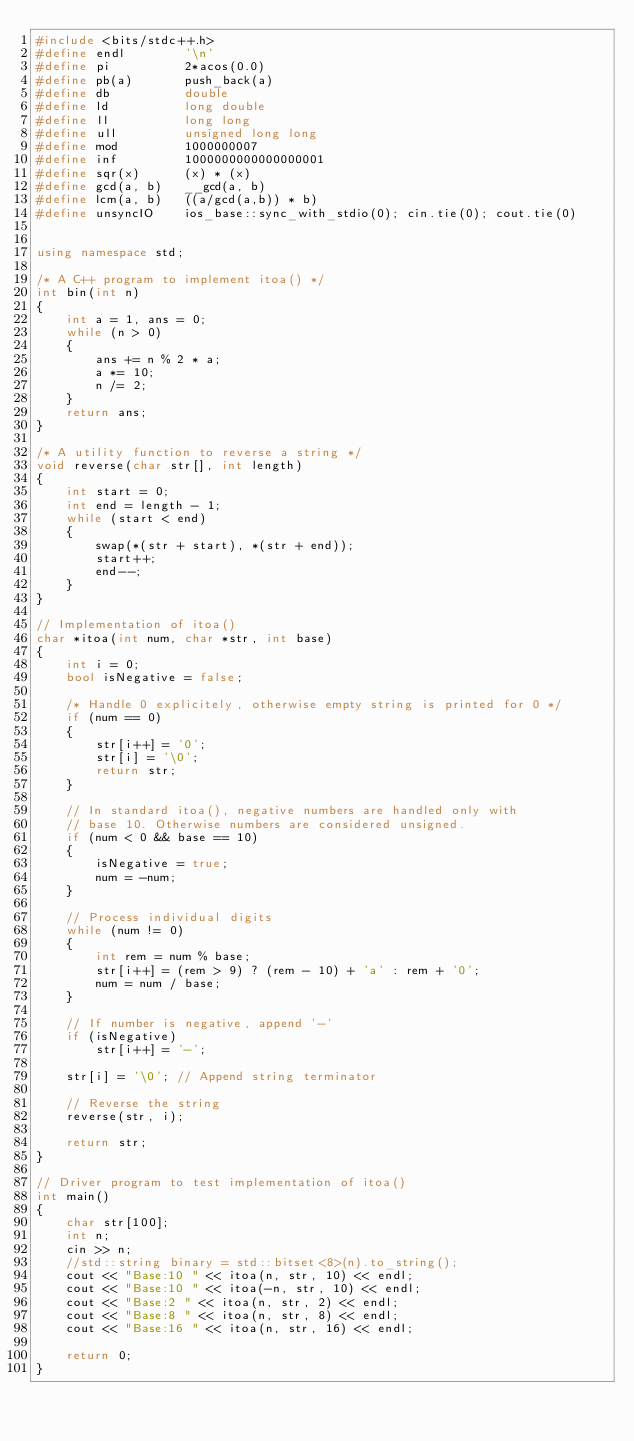Convert code to text. <code><loc_0><loc_0><loc_500><loc_500><_C++_>#include <bits/stdc++.h>
#define endl        '\n'
#define pi          2*acos(0.0)
#define pb(a)       push_back(a)
#define db          double
#define ld          long double
#define ll          long long
#define ull         unsigned long long
#define mod         1000000007
#define inf         1000000000000000001
#define sqr(x)      (x) * (x)
#define gcd(a, b)   __gcd(a, b)
#define lcm(a, b)   ((a/gcd(a,b)) * b) 
#define unsyncIO    ios_base::sync_with_stdio(0); cin.tie(0); cout.tie(0)


using namespace std;

/* A C++ program to implement itoa() */
int bin(int n)
{
    int a = 1, ans = 0;
    while (n > 0)
    {
        ans += n % 2 * a;
        a *= 10;
        n /= 2;
    }
    return ans;
}

/* A utility function to reverse a string */
void reverse(char str[], int length)
{
    int start = 0;
    int end = length - 1;
    while (start < end)
    {
        swap(*(str + start), *(str + end));
        start++;
        end--;
    }
}

// Implementation of itoa()
char *itoa(int num, char *str, int base)
{
    int i = 0;
    bool isNegative = false;

    /* Handle 0 explicitely, otherwise empty string is printed for 0 */
    if (num == 0)
    {
        str[i++] = '0';
        str[i] = '\0';
        return str;
    }

    // In standard itoa(), negative numbers are handled only with
    // base 10. Otherwise numbers are considered unsigned.
    if (num < 0 && base == 10)
    {
        isNegative = true;
        num = -num;
    }

    // Process individual digits
    while (num != 0)
    {
        int rem = num % base;
        str[i++] = (rem > 9) ? (rem - 10) + 'a' : rem + '0';
        num = num / base;
    }

    // If number is negative, append '-'
    if (isNegative)
        str[i++] = '-';

    str[i] = '\0'; // Append string terminator

    // Reverse the string
    reverse(str, i);

    return str;
}

// Driver program to test implementation of itoa()
int main()
{
    char str[100];
    int n;
    cin >> n;
    //std::string binary = std::bitset<8>(n).to_string();
    cout << "Base:10 " << itoa(n, str, 10) << endl;
    cout << "Base:10 " << itoa(-n, str, 10) << endl;
    cout << "Base:2 " << itoa(n, str, 2) << endl;
    cout << "Base:8 " << itoa(n, str, 8) << endl;
    cout << "Base:16 " << itoa(n, str, 16) << endl;

    return 0;
}
</code> 